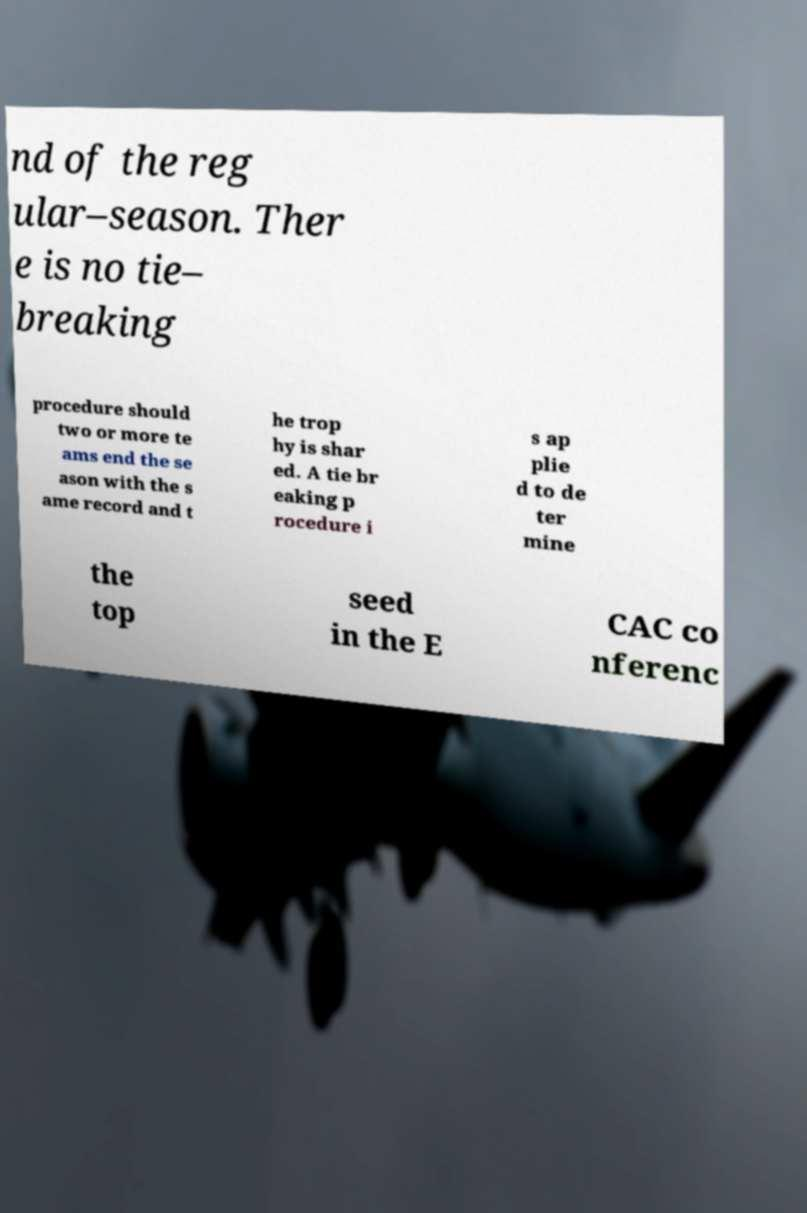Could you extract and type out the text from this image? nd of the reg ular–season. Ther e is no tie– breaking procedure should two or more te ams end the se ason with the s ame record and t he trop hy is shar ed. A tie br eaking p rocedure i s ap plie d to de ter mine the top seed in the E CAC co nferenc 